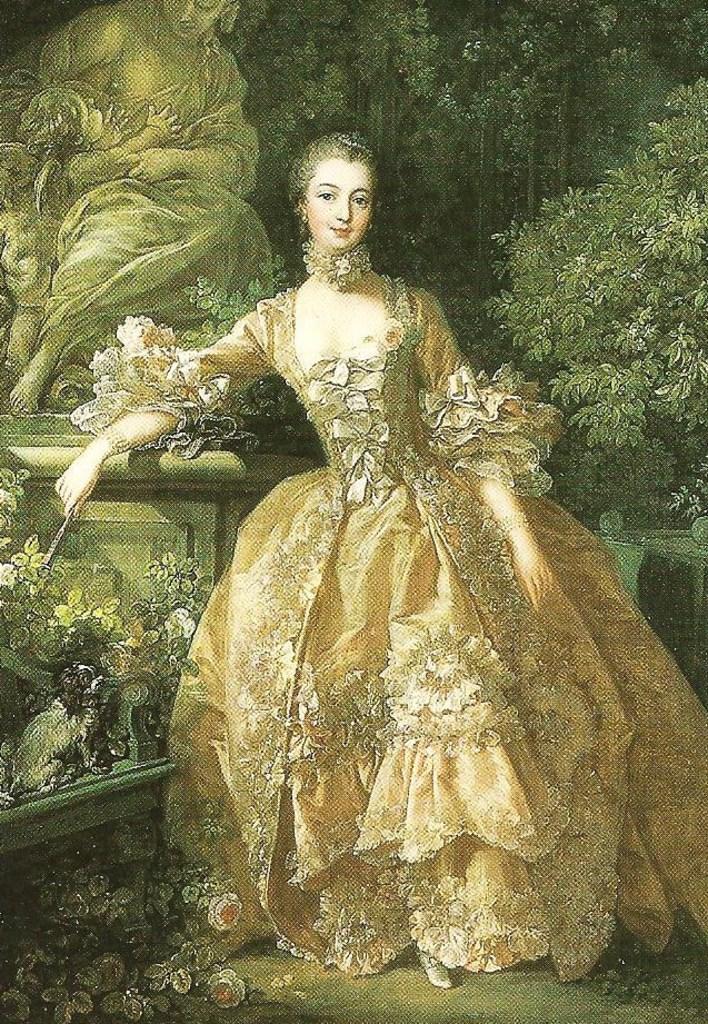Please provide a concise description of this image. In this image, we can see a painting. In the middle of the image, we can see a painting of a woman. In the background, we can see some painting of some plants, person. 